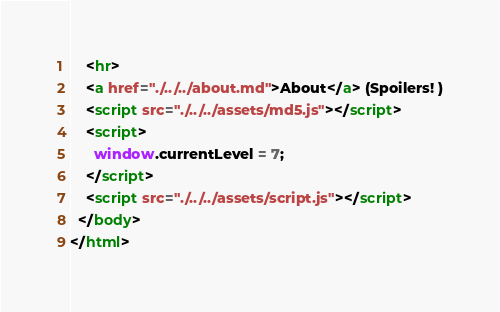<code> <loc_0><loc_0><loc_500><loc_500><_HTML_>    <hr>
    <a href="./../../about.md">About</a> (Spoilers! )
    <script src="./../../assets/md5.js"></script>
    <script>
      window.currentLevel = 7;
    </script>
    <script src="./../../assets/script.js"></script>
  </body>
</html></code> 